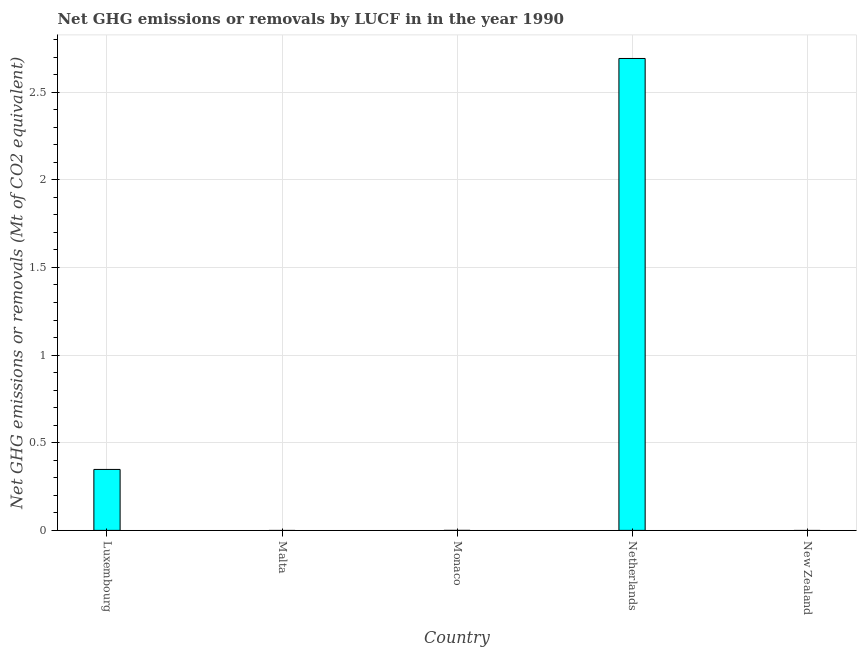Does the graph contain grids?
Ensure brevity in your answer.  Yes. What is the title of the graph?
Keep it short and to the point. Net GHG emissions or removals by LUCF in in the year 1990. What is the label or title of the X-axis?
Offer a terse response. Country. What is the label or title of the Y-axis?
Offer a terse response. Net GHG emissions or removals (Mt of CO2 equivalent). What is the ghg net emissions or removals in Luxembourg?
Your answer should be compact. 0.35. Across all countries, what is the maximum ghg net emissions or removals?
Ensure brevity in your answer.  2.69. Across all countries, what is the minimum ghg net emissions or removals?
Provide a succinct answer. 0. What is the sum of the ghg net emissions or removals?
Offer a terse response. 3.04. What is the average ghg net emissions or removals per country?
Provide a succinct answer. 0.61. What is the median ghg net emissions or removals?
Provide a short and direct response. 0. In how many countries, is the ghg net emissions or removals greater than 2.7 Mt?
Offer a very short reply. 0. Is the difference between the ghg net emissions or removals in Luxembourg and Netherlands greater than the difference between any two countries?
Keep it short and to the point. No. What is the difference between the highest and the lowest ghg net emissions or removals?
Offer a terse response. 2.69. How many countries are there in the graph?
Your response must be concise. 5. What is the difference between two consecutive major ticks on the Y-axis?
Keep it short and to the point. 0.5. Are the values on the major ticks of Y-axis written in scientific E-notation?
Offer a terse response. No. What is the Net GHG emissions or removals (Mt of CO2 equivalent) in Luxembourg?
Your answer should be very brief. 0.35. What is the Net GHG emissions or removals (Mt of CO2 equivalent) in Monaco?
Make the answer very short. 0. What is the Net GHG emissions or removals (Mt of CO2 equivalent) of Netherlands?
Keep it short and to the point. 2.69. What is the Net GHG emissions or removals (Mt of CO2 equivalent) of New Zealand?
Make the answer very short. 0. What is the difference between the Net GHG emissions or removals (Mt of CO2 equivalent) in Luxembourg and Netherlands?
Your answer should be compact. -2.34. What is the ratio of the Net GHG emissions or removals (Mt of CO2 equivalent) in Luxembourg to that in Netherlands?
Offer a very short reply. 0.13. 